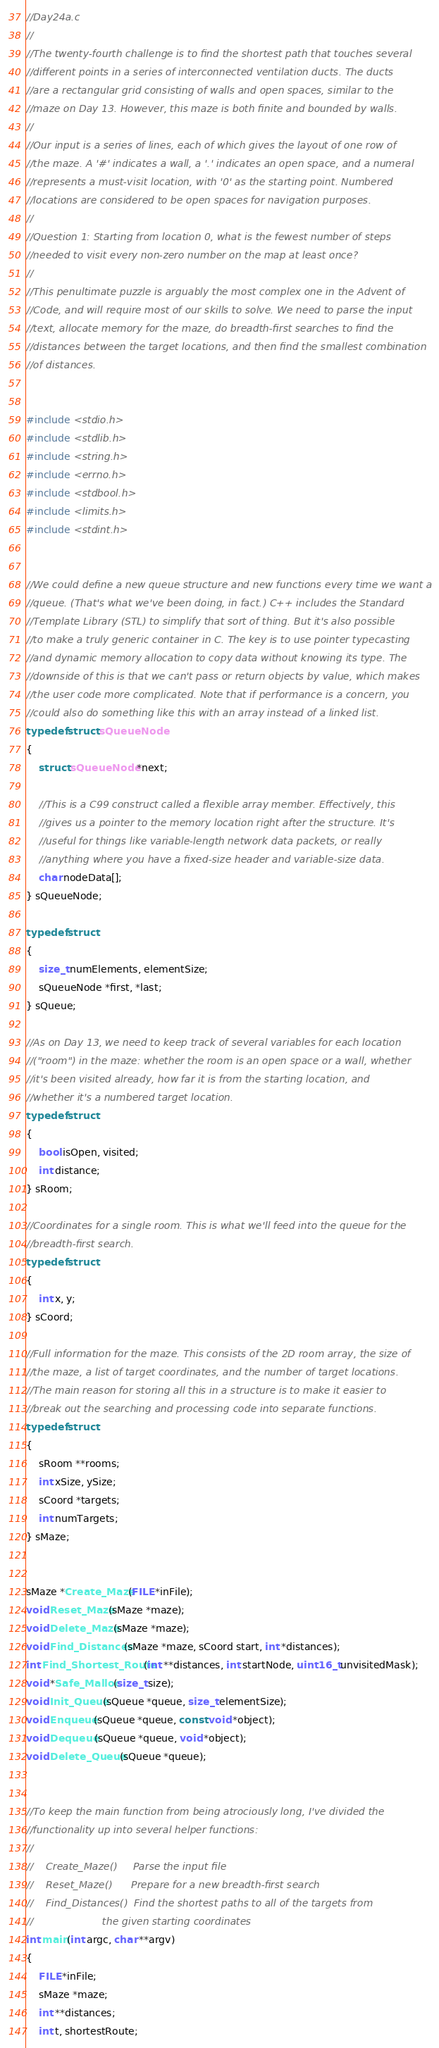<code> <loc_0><loc_0><loc_500><loc_500><_C_>//Day24a.c
//
//The twenty-fourth challenge is to find the shortest path that touches several
//different points in a series of interconnected ventilation ducts. The ducts
//are a rectangular grid consisting of walls and open spaces, similar to the
//maze on Day 13. However, this maze is both finite and bounded by walls.
//
//Our input is a series of lines, each of which gives the layout of one row of
//the maze. A '#' indicates a wall, a '.' indicates an open space, and a numeral
//represents a must-visit location, with '0' as the starting point. Numbered
//locations are considered to be open spaces for navigation purposes.
//
//Question 1: Starting from location 0, what is the fewest number of steps
//needed to visit every non-zero number on the map at least once?
//
//This penultimate puzzle is arguably the most complex one in the Advent of
//Code, and will require most of our skills to solve. We need to parse the input
//text, allocate memory for the maze, do breadth-first searches to find the
//distances between the target locations, and then find the smallest combination
//of distances. 


#include <stdio.h>
#include <stdlib.h>
#include <string.h>
#include <errno.h>
#include <stdbool.h>
#include <limits.h>
#include <stdint.h>


//We could define a new queue structure and new functions every time we want a
//queue. (That's what we've been doing, in fact.) C++ includes the Standard
//Template Library (STL) to simplify that sort of thing. But it's also possible
//to make a truly generic container in C. The key is to use pointer typecasting
//and dynamic memory allocation to copy data without knowing its type. The
//downside of this is that we can't pass or return objects by value, which makes
//the user code more complicated. Note that if performance is a concern, you
//could also do something like this with an array instead of a linked list.
typedef struct sQueueNode
{
	struct sQueueNode *next;
	
	//This is a C99 construct called a flexible array member. Effectively, this
	//gives us a pointer to the memory location right after the structure. It's
	//useful for things like variable-length network data packets, or really
	//anything where you have a fixed-size header and variable-size data.
	char nodeData[];
} sQueueNode;
	
typedef struct
{
	size_t numElements, elementSize;
	sQueueNode *first, *last;
} sQueue;

//As on Day 13, we need to keep track of several variables for each location
//("room") in the maze: whether the room is an open space or a wall, whether
//it's been visited already, how far it is from the starting location, and
//whether it's a numbered target location.
typedef struct
{
	bool isOpen, visited;
	int distance;
} sRoom;

//Coordinates for a single room. This is what we'll feed into the queue for the
//breadth-first search.
typedef struct
{
	int x, y;
} sCoord;

//Full information for the maze. This consists of the 2D room array, the size of
//the maze, a list of target coordinates, and the number of target locations.
//The main reason for storing all this in a structure is to make it easier to
//break out the searching and processing code into separate functions.
typedef struct
{
	sRoom **rooms;
	int xSize, ySize;
	sCoord *targets;
	int numTargets;
} sMaze;


sMaze *Create_Maze(FILE *inFile);
void Reset_Maze(sMaze *maze);
void Delete_Maze(sMaze *maze);
void Find_Distances(sMaze *maze, sCoord start, int *distances);
int Find_Shortest_Route(int **distances, int startNode, uint16_t unvisitedMask);
void *Safe_Malloc(size_t size);
void Init_Queue(sQueue *queue, size_t elementSize);
void Enqueue(sQueue *queue, const void *object);
void Dequeue(sQueue *queue, void *object);
void Delete_Queue(sQueue *queue);


//To keep the main function from being atrociously long, I've divided the
//functionality up into several helper functions:
//
//    Create_Maze()     Parse the input file
//    Reset_Maze()      Prepare for a new breadth-first search
//    Find_Distances()  Find the shortest paths to all of the targets from
//                      the given starting coordinates
int main(int argc, char **argv)
{
	FILE *inFile;
	sMaze *maze;
	int **distances;
	int t, shortestRoute;</code> 